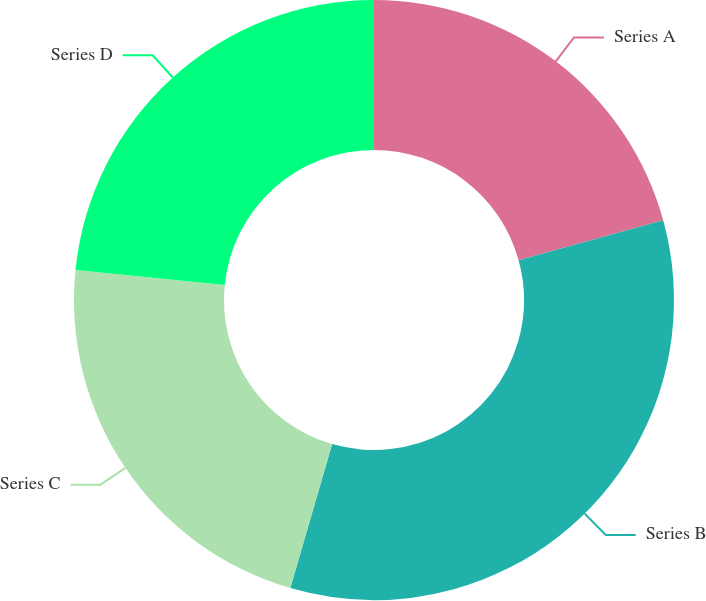Convert chart to OTSL. <chart><loc_0><loc_0><loc_500><loc_500><pie_chart><fcel>Series A<fcel>Series B<fcel>Series C<fcel>Series D<nl><fcel>20.72%<fcel>33.78%<fcel>22.1%<fcel>23.4%<nl></chart> 